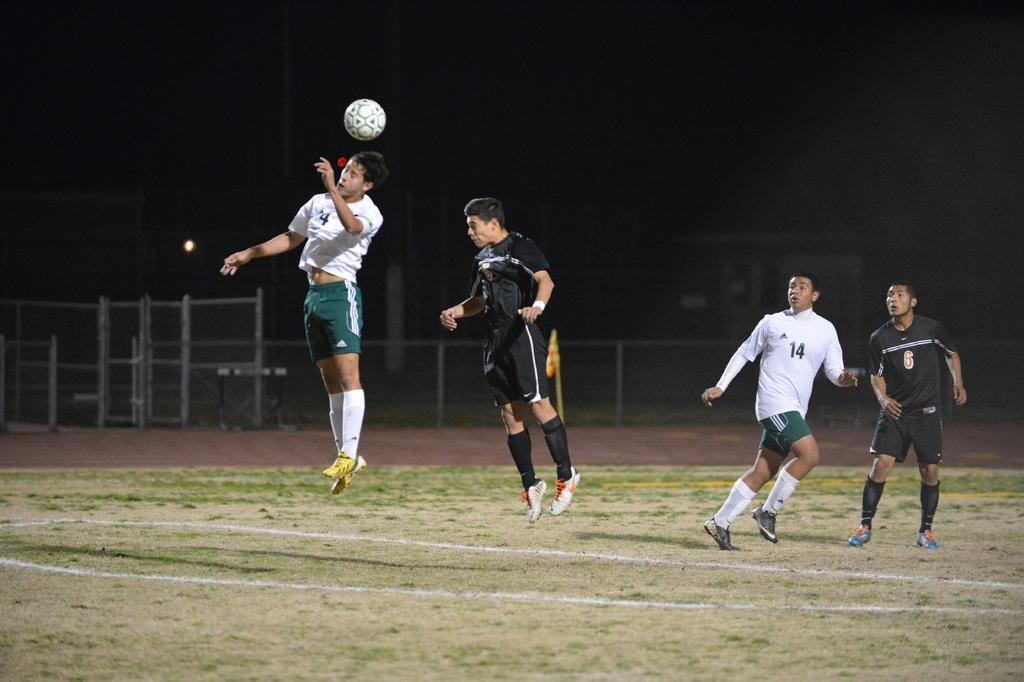How many people are present in the image? There are four persons in the image. What are the persons doing in the image? The persons are playing in the ground. What object can be seen in the image that is commonly used in games? There is a ball in the image. Can you describe the source of light in the image? There is a light in the image. What company is sponsoring the game in the image? There is no indication of a company sponsoring the game in the image. Can you tell me how many steps lead to the cellar in the image? There is no mention of a cellar in the image. 